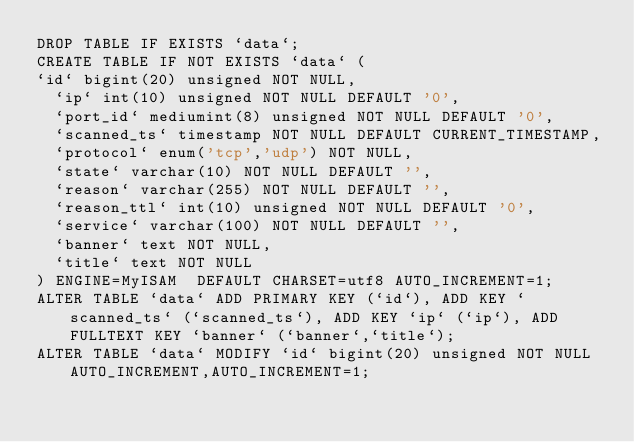<code> <loc_0><loc_0><loc_500><loc_500><_SQL_>DROP TABLE IF EXISTS `data`;
CREATE TABLE IF NOT EXISTS `data` (
`id` bigint(20) unsigned NOT NULL,
  `ip` int(10) unsigned NOT NULL DEFAULT '0',
  `port_id` mediumint(8) unsigned NOT NULL DEFAULT '0',
  `scanned_ts` timestamp NOT NULL DEFAULT CURRENT_TIMESTAMP,
  `protocol` enum('tcp','udp') NOT NULL,
  `state` varchar(10) NOT NULL DEFAULT '',
  `reason` varchar(255) NOT NULL DEFAULT '',
  `reason_ttl` int(10) unsigned NOT NULL DEFAULT '0',
  `service` varchar(100) NOT NULL DEFAULT '',
  `banner` text NOT NULL,
  `title` text NOT NULL
) ENGINE=MyISAM  DEFAULT CHARSET=utf8 AUTO_INCREMENT=1;
ALTER TABLE `data` ADD PRIMARY KEY (`id`), ADD KEY `scanned_ts` (`scanned_ts`), ADD KEY `ip` (`ip`), ADD FULLTEXT KEY `banner` (`banner`,`title`);
ALTER TABLE `data` MODIFY `id` bigint(20) unsigned NOT NULL AUTO_INCREMENT,AUTO_INCREMENT=1;
</code> 